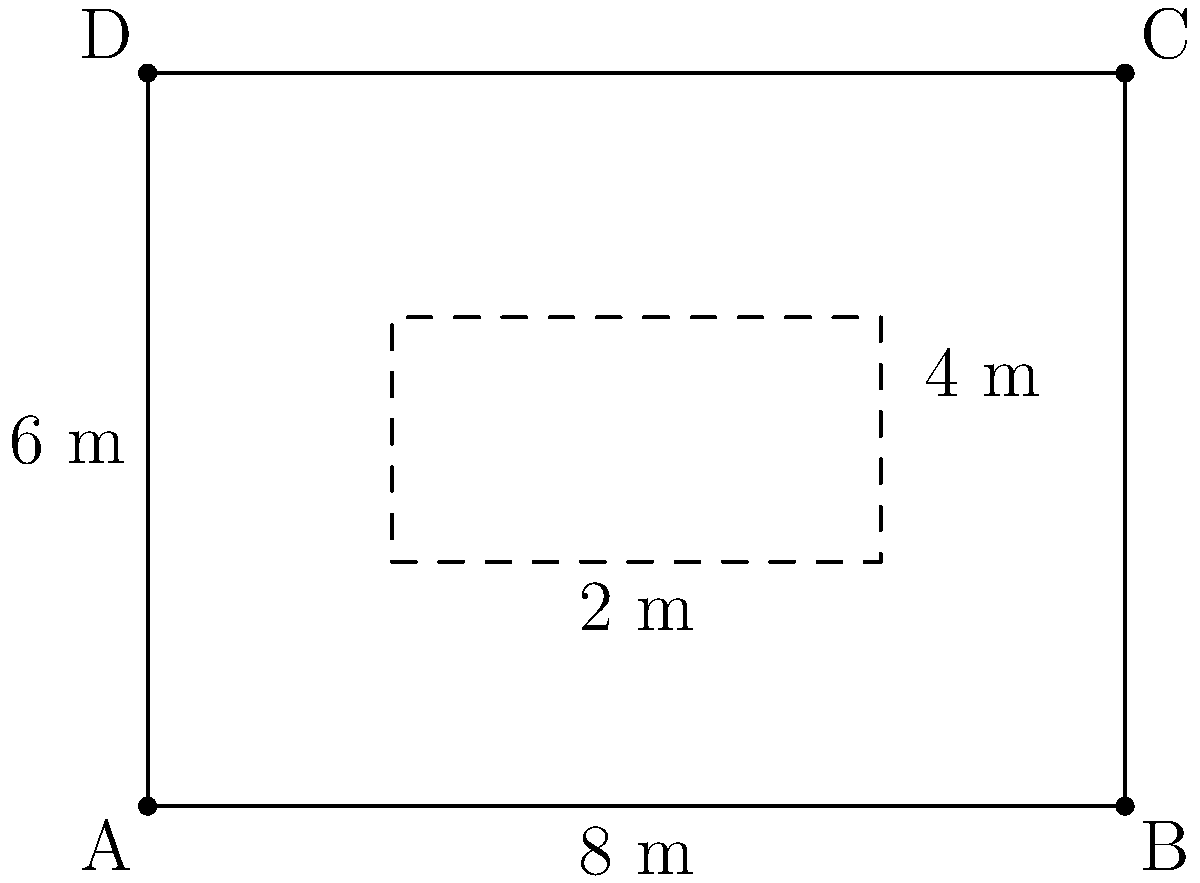You're redesigning a rectangular guest room that measures 8 m by 6 m. To maximize floor space, you decide to place a queen-sized bed (2 m × 2 m) in one corner of the room. What is the maximum area of free floor space you can achieve after placing the bed? Let's approach this step-by-step:

1) The total area of the room is:
   $$A_{room} = 8 \text{ m} \times 6 \text{ m} = 48 \text{ m}^2$$

2) The area occupied by the bed is:
   $$A_{bed} = 2 \text{ m} \times 2 \text{ m} = 4 \text{ m}^2$$

3) To maximize free floor space, we should place the bed in one of the corners of the room. This way, we don't create any unusable spaces around the bed.

4) The free floor space will be the difference between the total room area and the bed area:
   $$A_{free} = A_{room} - A_{bed}$$

5) Substituting the values:
   $$A_{free} = 48 \text{ m}^2 - 4 \text{ m}^2 = 44 \text{ m}^2$$

Therefore, the maximum area of free floor space you can achieve is 44 m².
Answer: 44 m² 